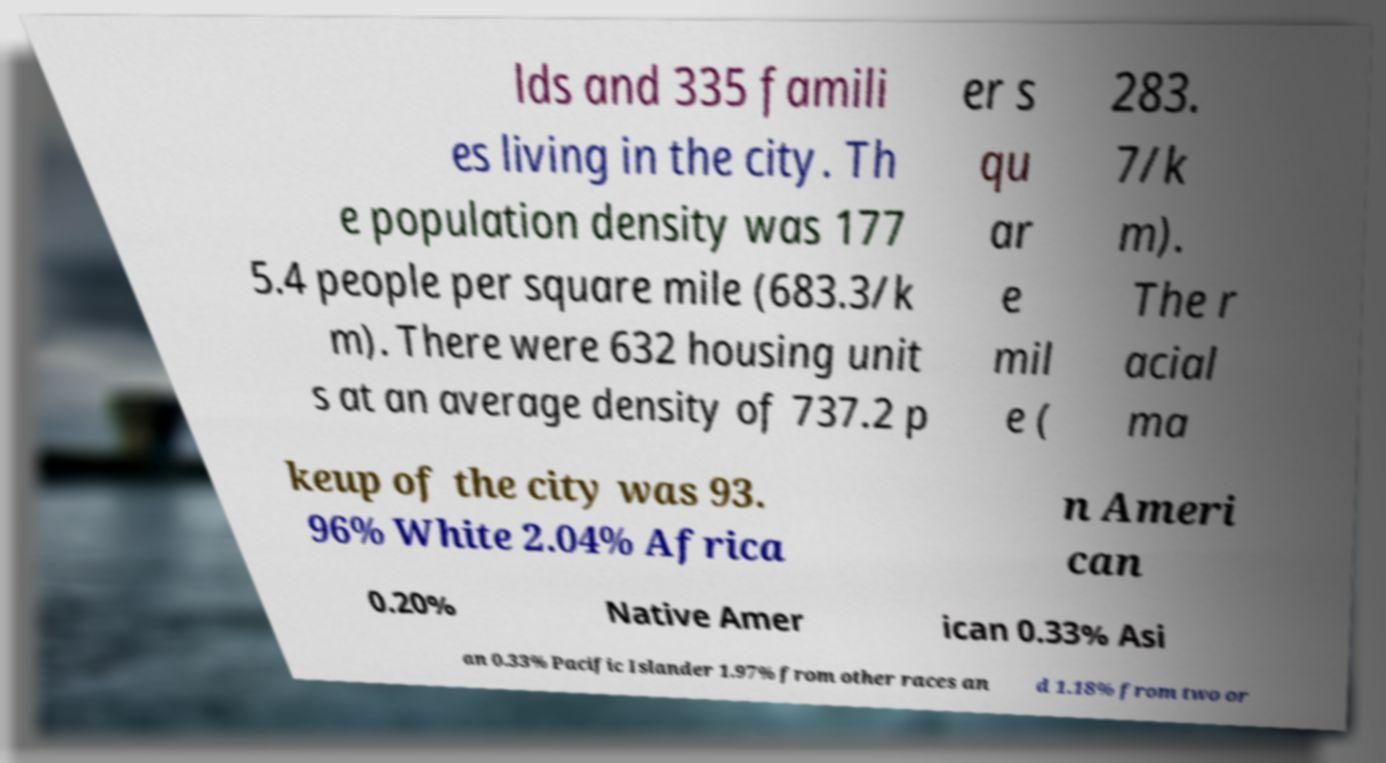Could you assist in decoding the text presented in this image and type it out clearly? lds and 335 famili es living in the city. Th e population density was 177 5.4 people per square mile (683.3/k m). There were 632 housing unit s at an average density of 737.2 p er s qu ar e mil e ( 283. 7/k m). The r acial ma keup of the city was 93. 96% White 2.04% Africa n Ameri can 0.20% Native Amer ican 0.33% Asi an 0.33% Pacific Islander 1.97% from other races an d 1.18% from two or 